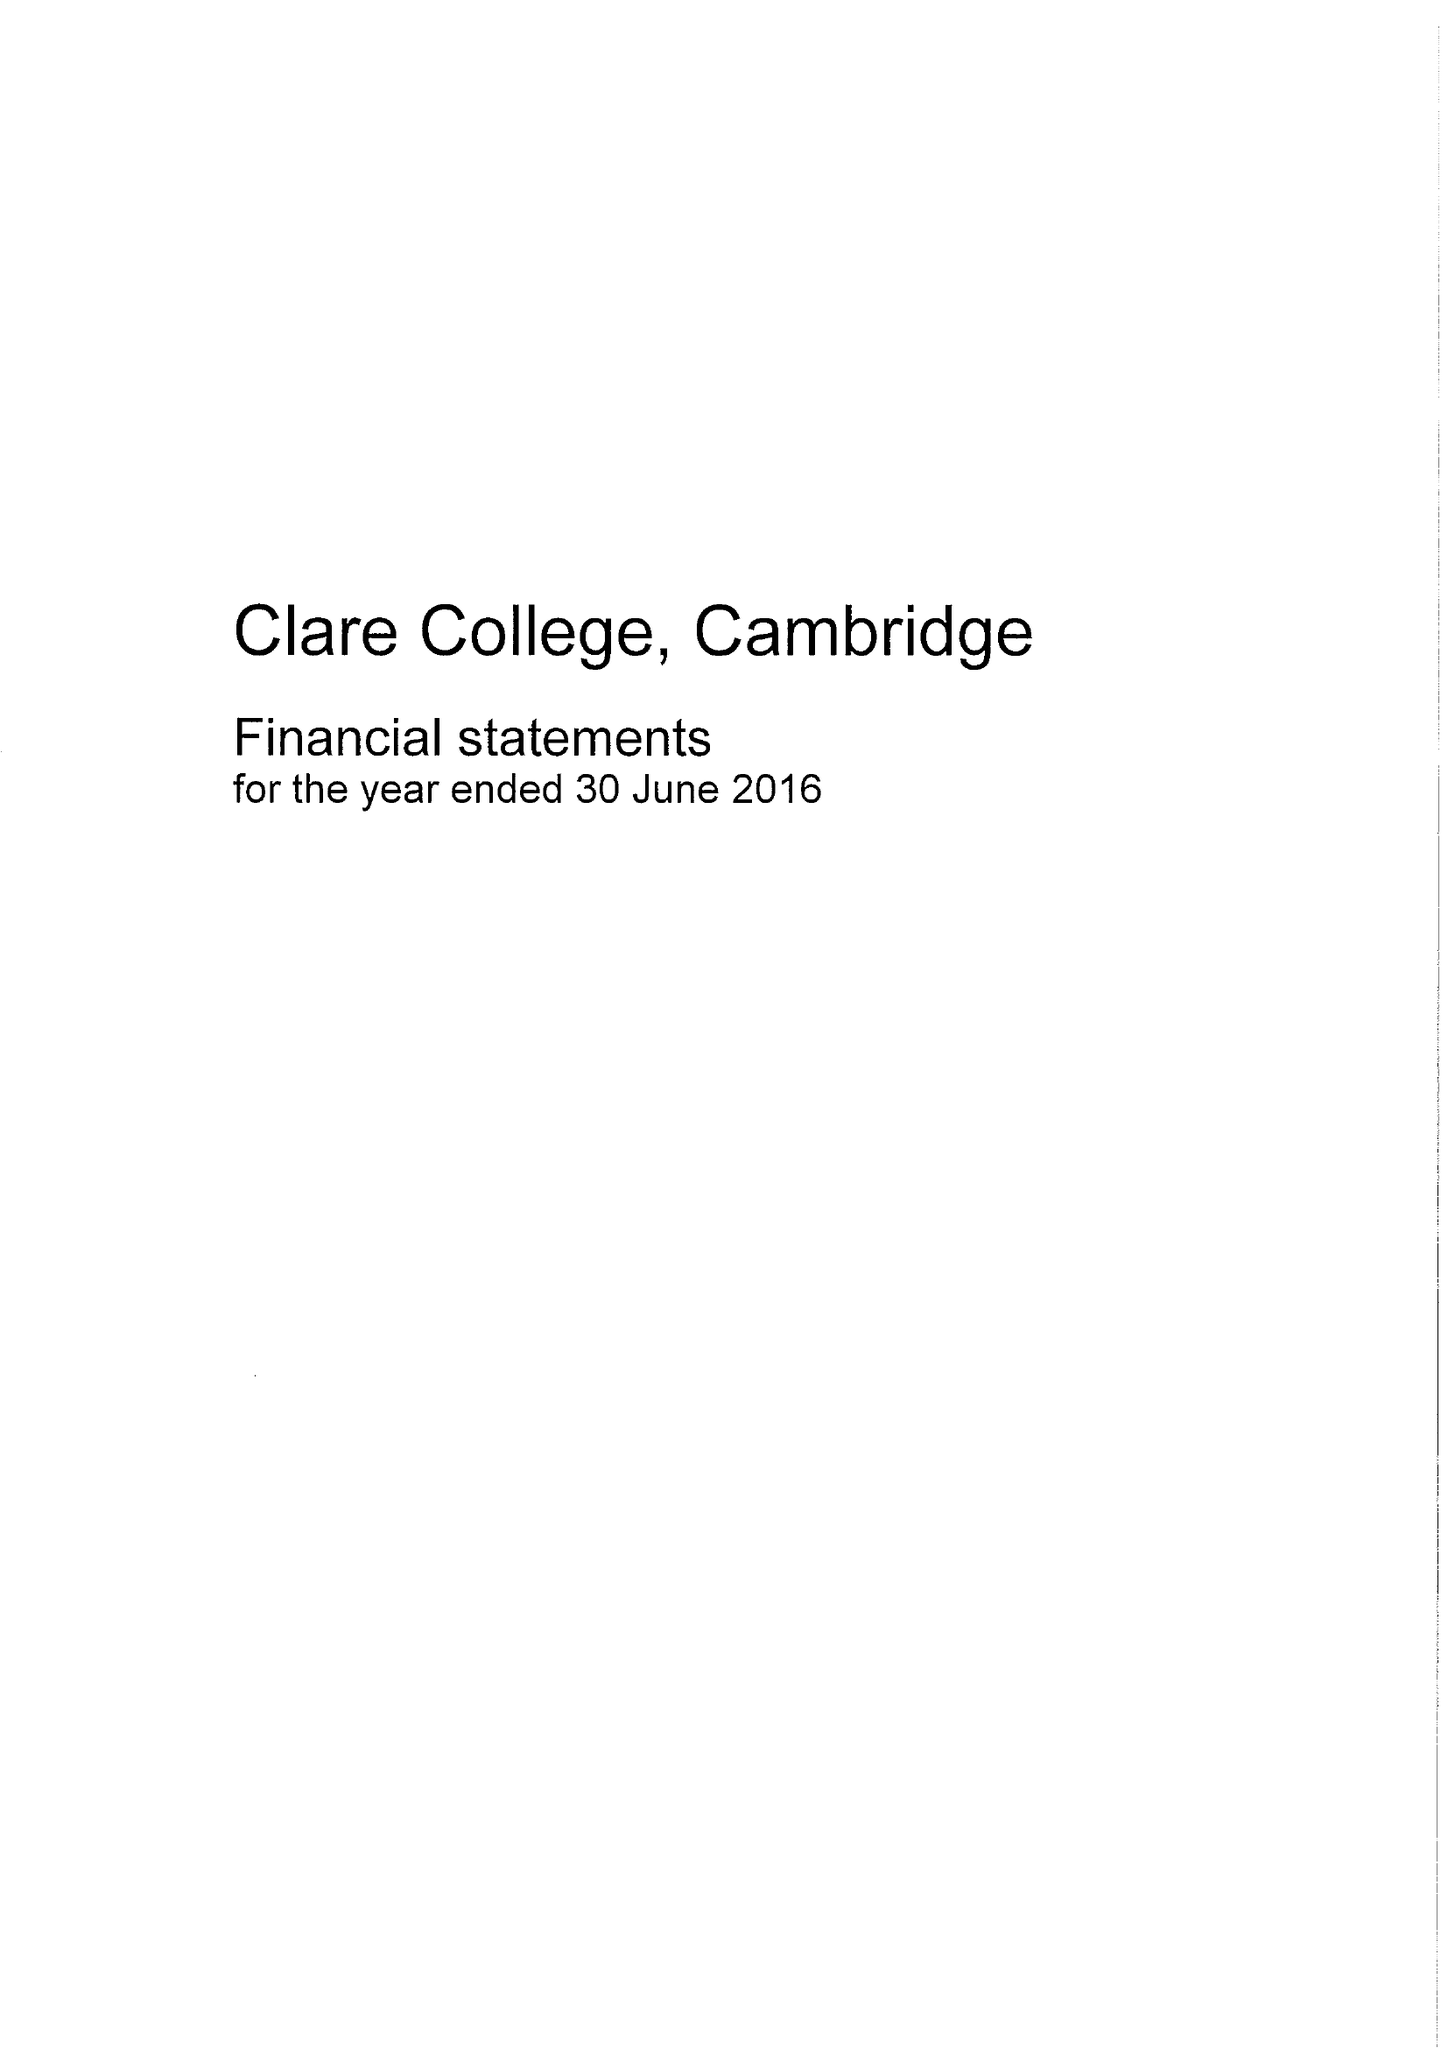What is the value for the income_annually_in_british_pounds?
Answer the question using a single word or phrase. 13346000.00 